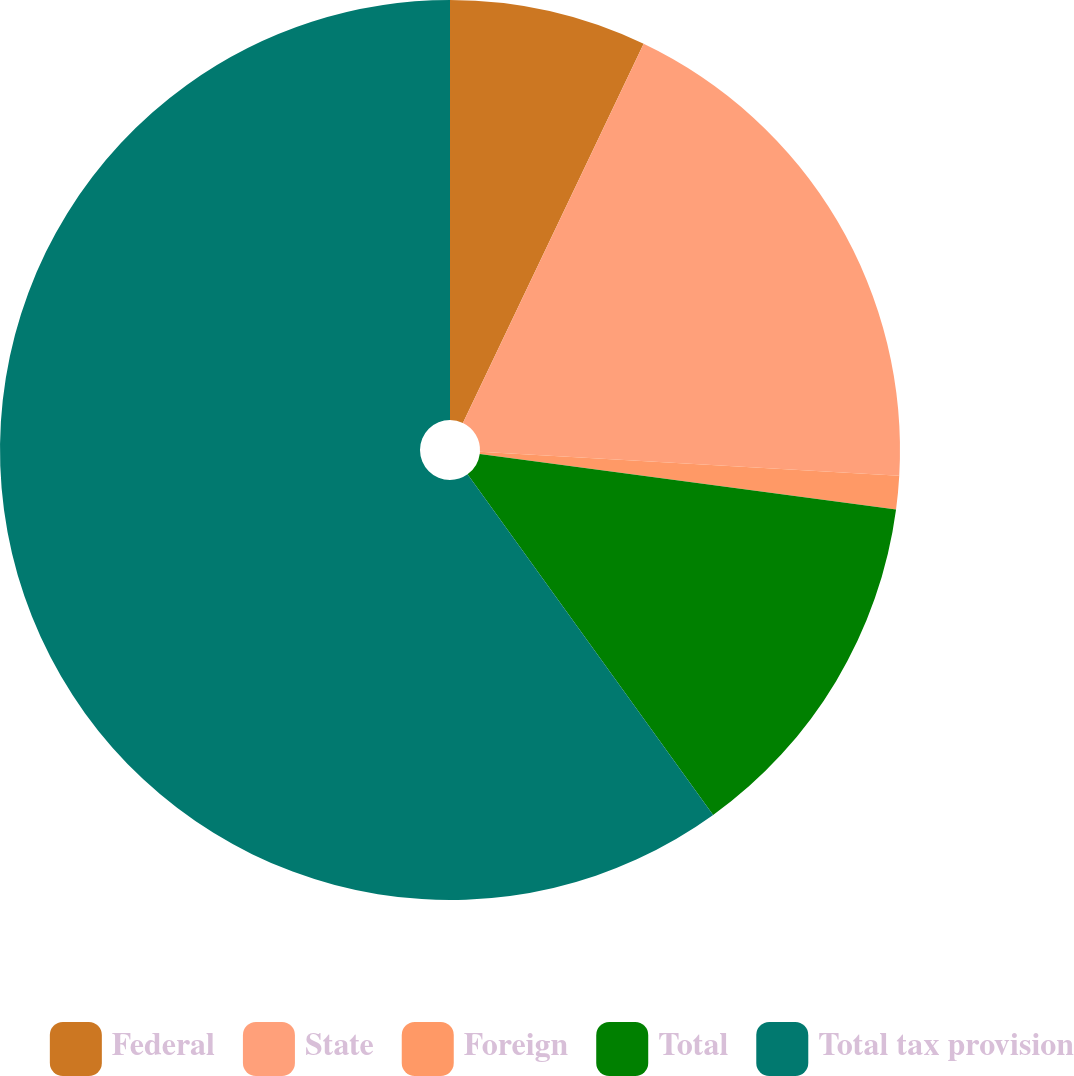Convert chart. <chart><loc_0><loc_0><loc_500><loc_500><pie_chart><fcel>Federal<fcel>State<fcel>Foreign<fcel>Total<fcel>Total tax provision<nl><fcel>7.08%<fcel>18.83%<fcel>1.2%<fcel>12.95%<fcel>59.94%<nl></chart> 